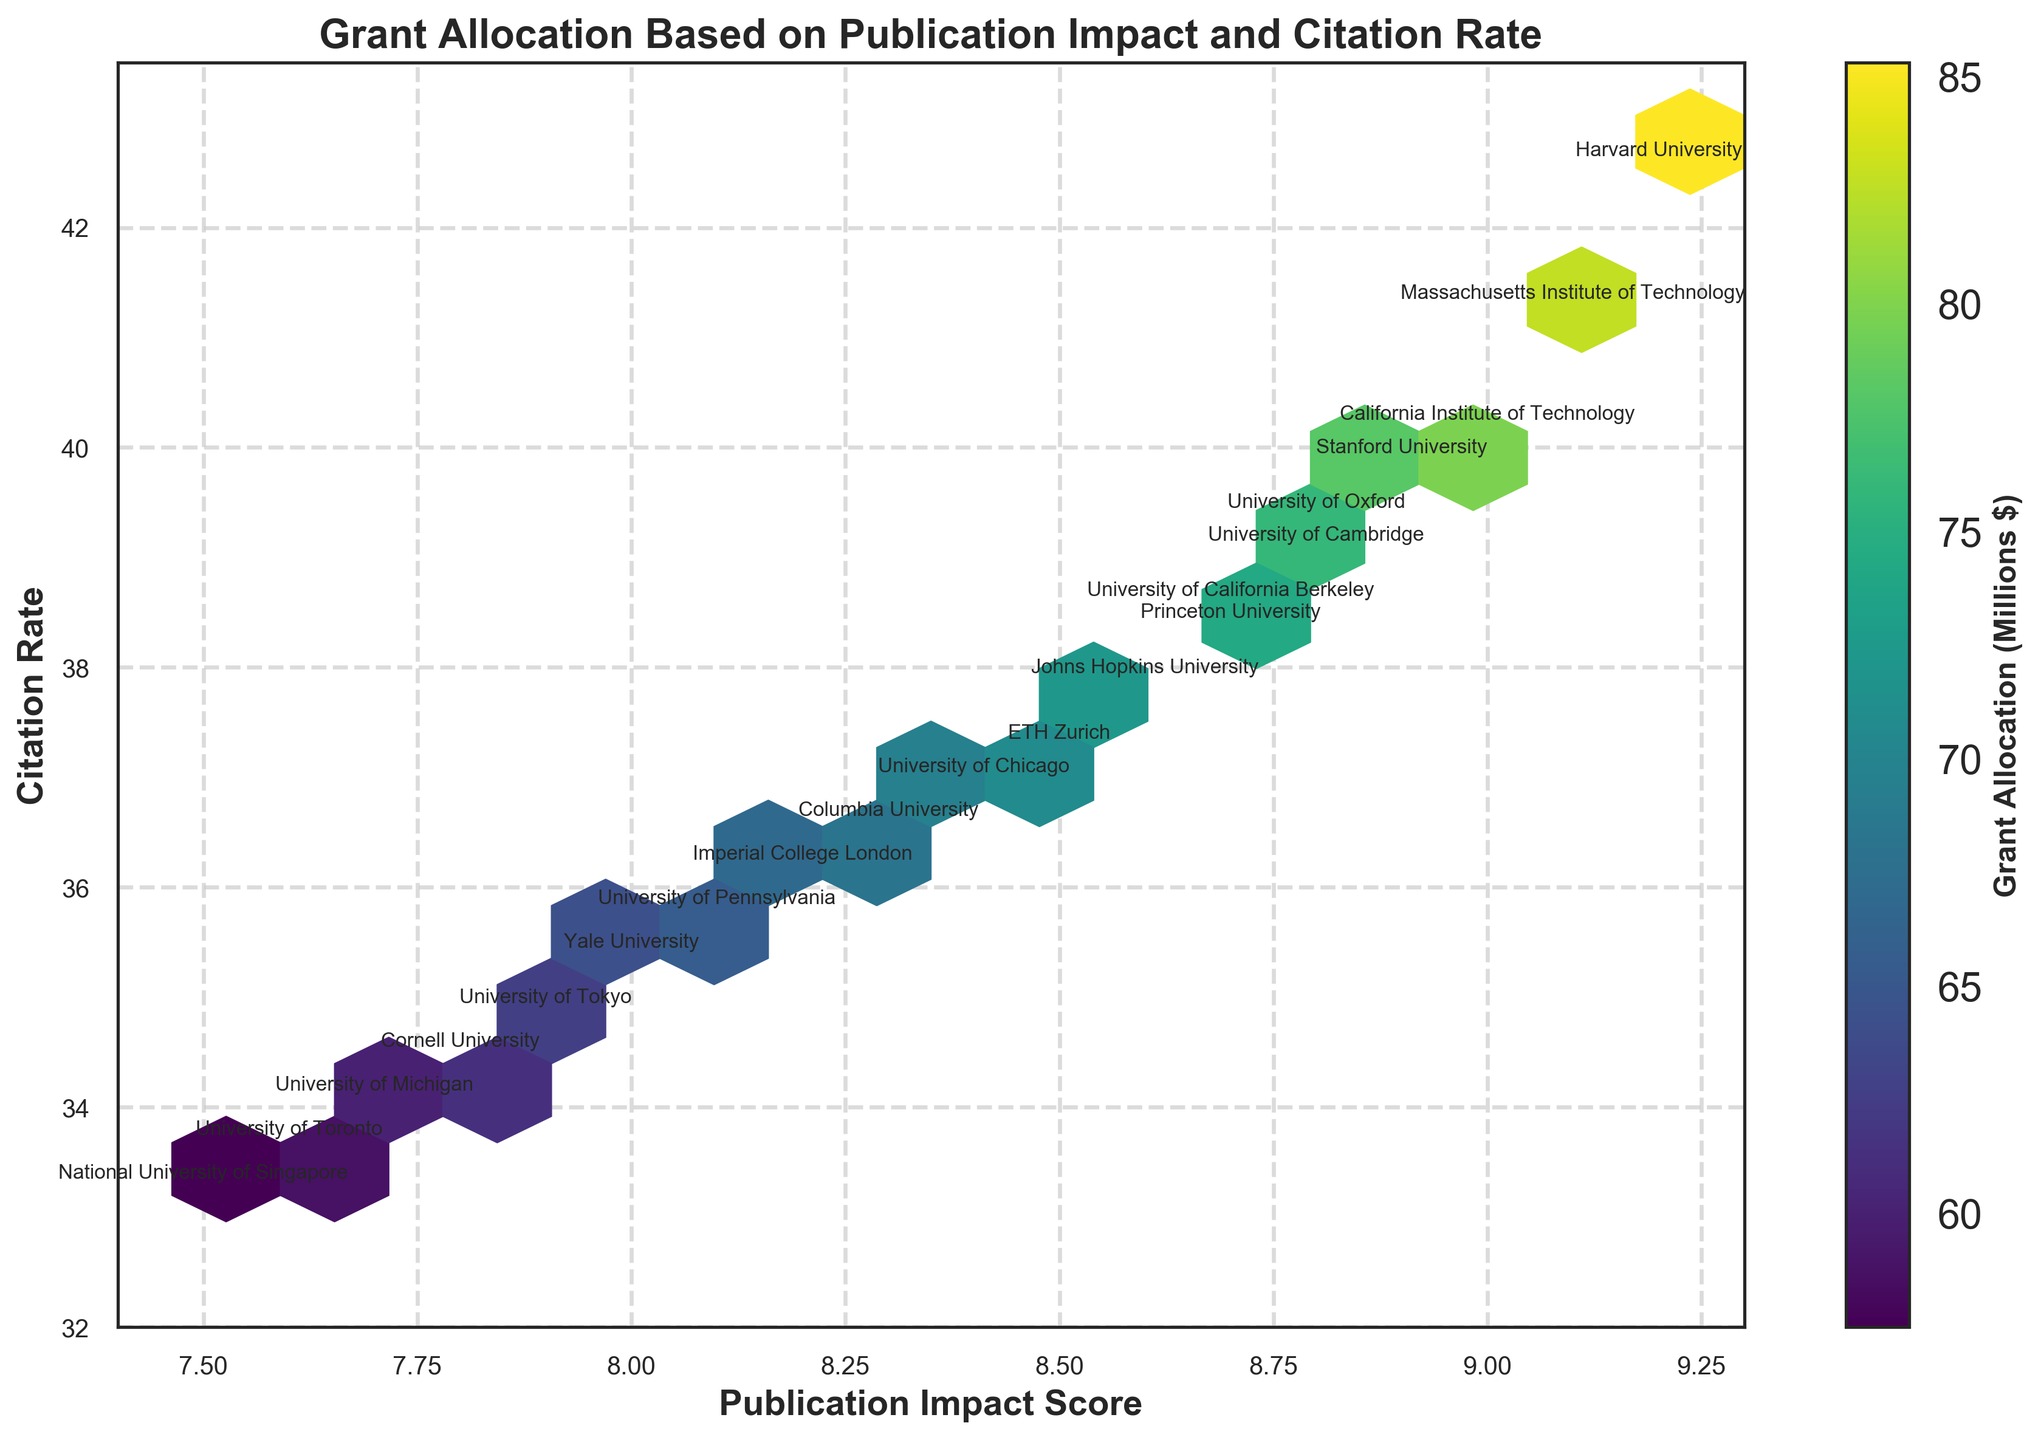What is the title of the figure? The title is usually placed at the top of the figure and can be read directly.
Answer: Grant Allocation Based on Publication Impact and Citation Rate What ranges are indicated on the x-axis and y-axis? The x-axis represents 'Publication Impact Score', ranging from 7.4 to 9.3. The y-axis represents 'Citation Rate', ranging from 32 to 43.5.
Answer: 7.4 to 9.3; 32 to 43.5 How does the color represent grant allocation in the plot? The figure uses a color bar to indicate grant allocation, where different shades represent different grant values, with darker colors representing higher grants.
Answer: Darker colors represent higher grants Which institution has the highest Publication Impact Score and Citation Rate? By looking at the annotated points on the hexbin plot, the institution with the highest values in both metrics is 'Harvard University'.
Answer: Harvard University What is the general trend between Publication Impact Score and Grant Allocation? Higher Publication Impact Scores generally correlate with higher Grant Allocations. This is indicated by the denser aggregation of darker-colored hexagons in higher ranges of the Publication Impact Score.
Answer: Positive correlation Which institutions lie close to the center of the hexagon bins with the highest grant allocations? By examining the locations annotated with institutions close to the darker hexagon bins, 'Harvard University', 'Massachusetts Institute of Technology', and 'Stanford University' lie close to these bins.
Answer: Harvard University, Massachusetts Institute of Technology, Stanford University Do higher Citation Rates always mean higher Grant Allocations? While there is a general trend (denser darker hexagons), some institutions with high Citation Rates do not always align with the highest Grant Allocations. For instance, 'University of Pennsylvania' has a relatively high Citation Rate but a moderate Grant Allocation.
Answer: Not always Is there an institution that has a high Publication Impact Score but relatively low Citation Rate? 'University of Tokyo' appears to have a high Publication Impact Score but a lower Citation Rate compared to other institutions with similar impact scores.
Answer: University of Tokyo Which institution has the lowest Grant Allocation and where is it located on the plot? By examining the color bar and annotated positions, 'National University of Singapore' has the lowest Grant Allocation and is located towards the bottom left of the plot.
Answer: National University of Singapore Is there a noticeable difference in grant allocation between institutions in the U.S. and those in other countries? U.S. institutions generally have higher grant allocations as indicated by denser darker hexagons around them, compared to institutions like 'ETH Zurich' or 'National University of Singapore'.
Answer: Yes 